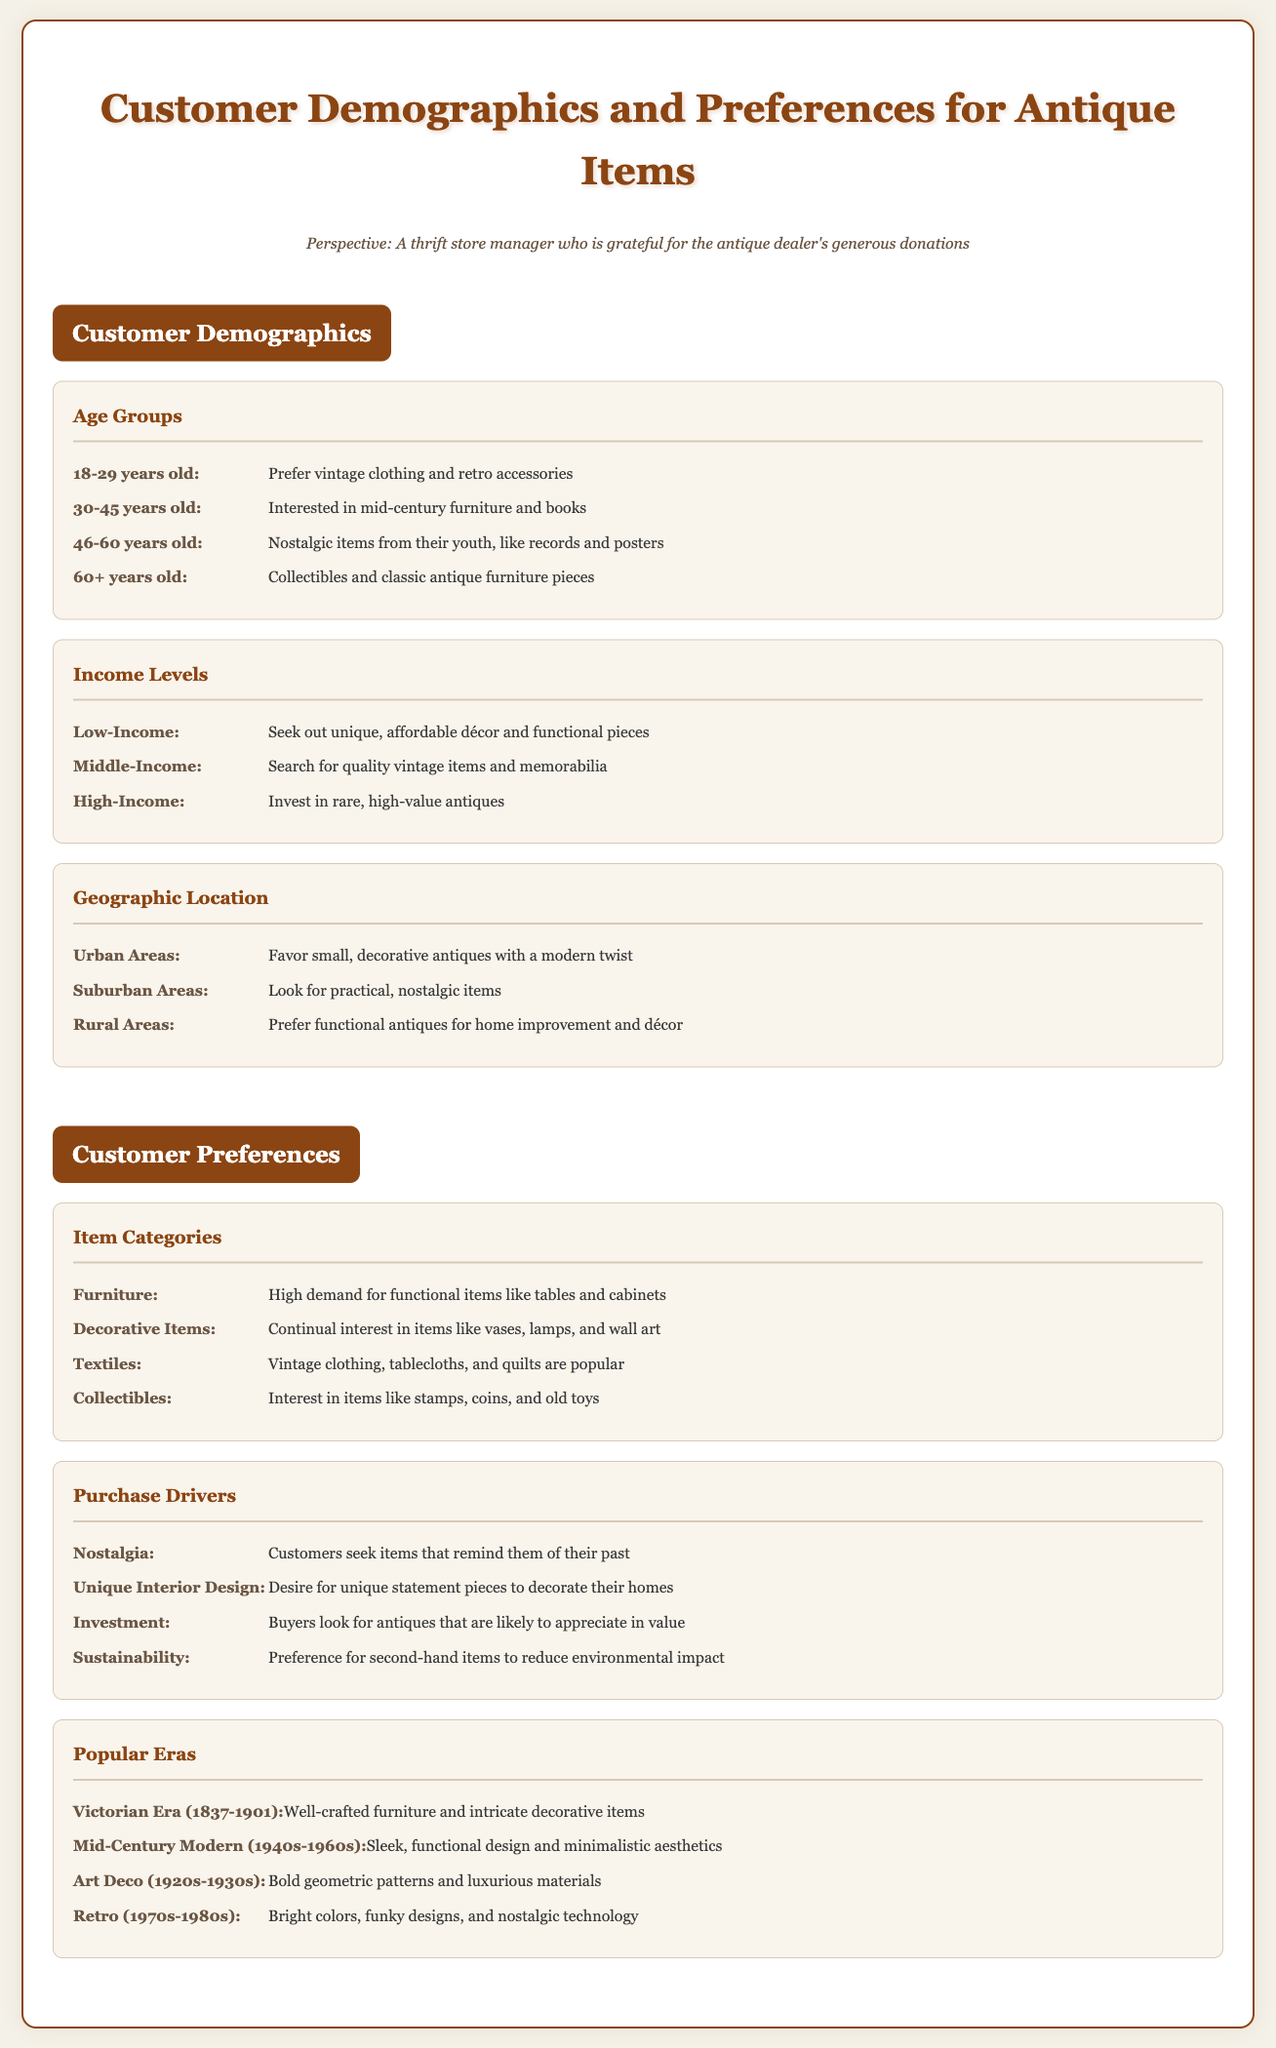What percentage of customers are in the 18-29 age group? The document does not specify a percentage, but indicates their preferences for vintage clothing and retro accessories.
Answer: N/A What type of items do 46-60 year olds prefer? The document states that this age group prefers nostalgic items from their youth, like records and posters.
Answer: Nostalgic items from their youth, like records and posters What do middle-income customers search for? The document mentions that middle-income customers search for quality vintage items and memorabilia.
Answer: Quality vintage items and memorabilia Which antique items do urban customers favor? The document indicates that urban customers favor small, decorative antiques with a modern twist.
Answer: Small, decorative antiques with a modern twist What is a major driver for antique purchases? The document lists several purchase drivers, one of which is nostalgia as customers seek items that remind them of their past.
Answer: Nostalgia Which item category has high demand for functional items? The document states that furniture has high demand for functional items like tables and cabinets.
Answer: Furniture What was a popular era known for bold geometric patterns? The document identifies the Art Deco era (1920s-1930s) as known for bold geometric patterns and luxurious materials.
Answer: Art Deco (1920s-1930s) What do rural customers prefer in terms of antiques? According to the document, rural customers prefer functional antiques for home improvement and décor.
Answer: Functional antiques for home improvement and décor 